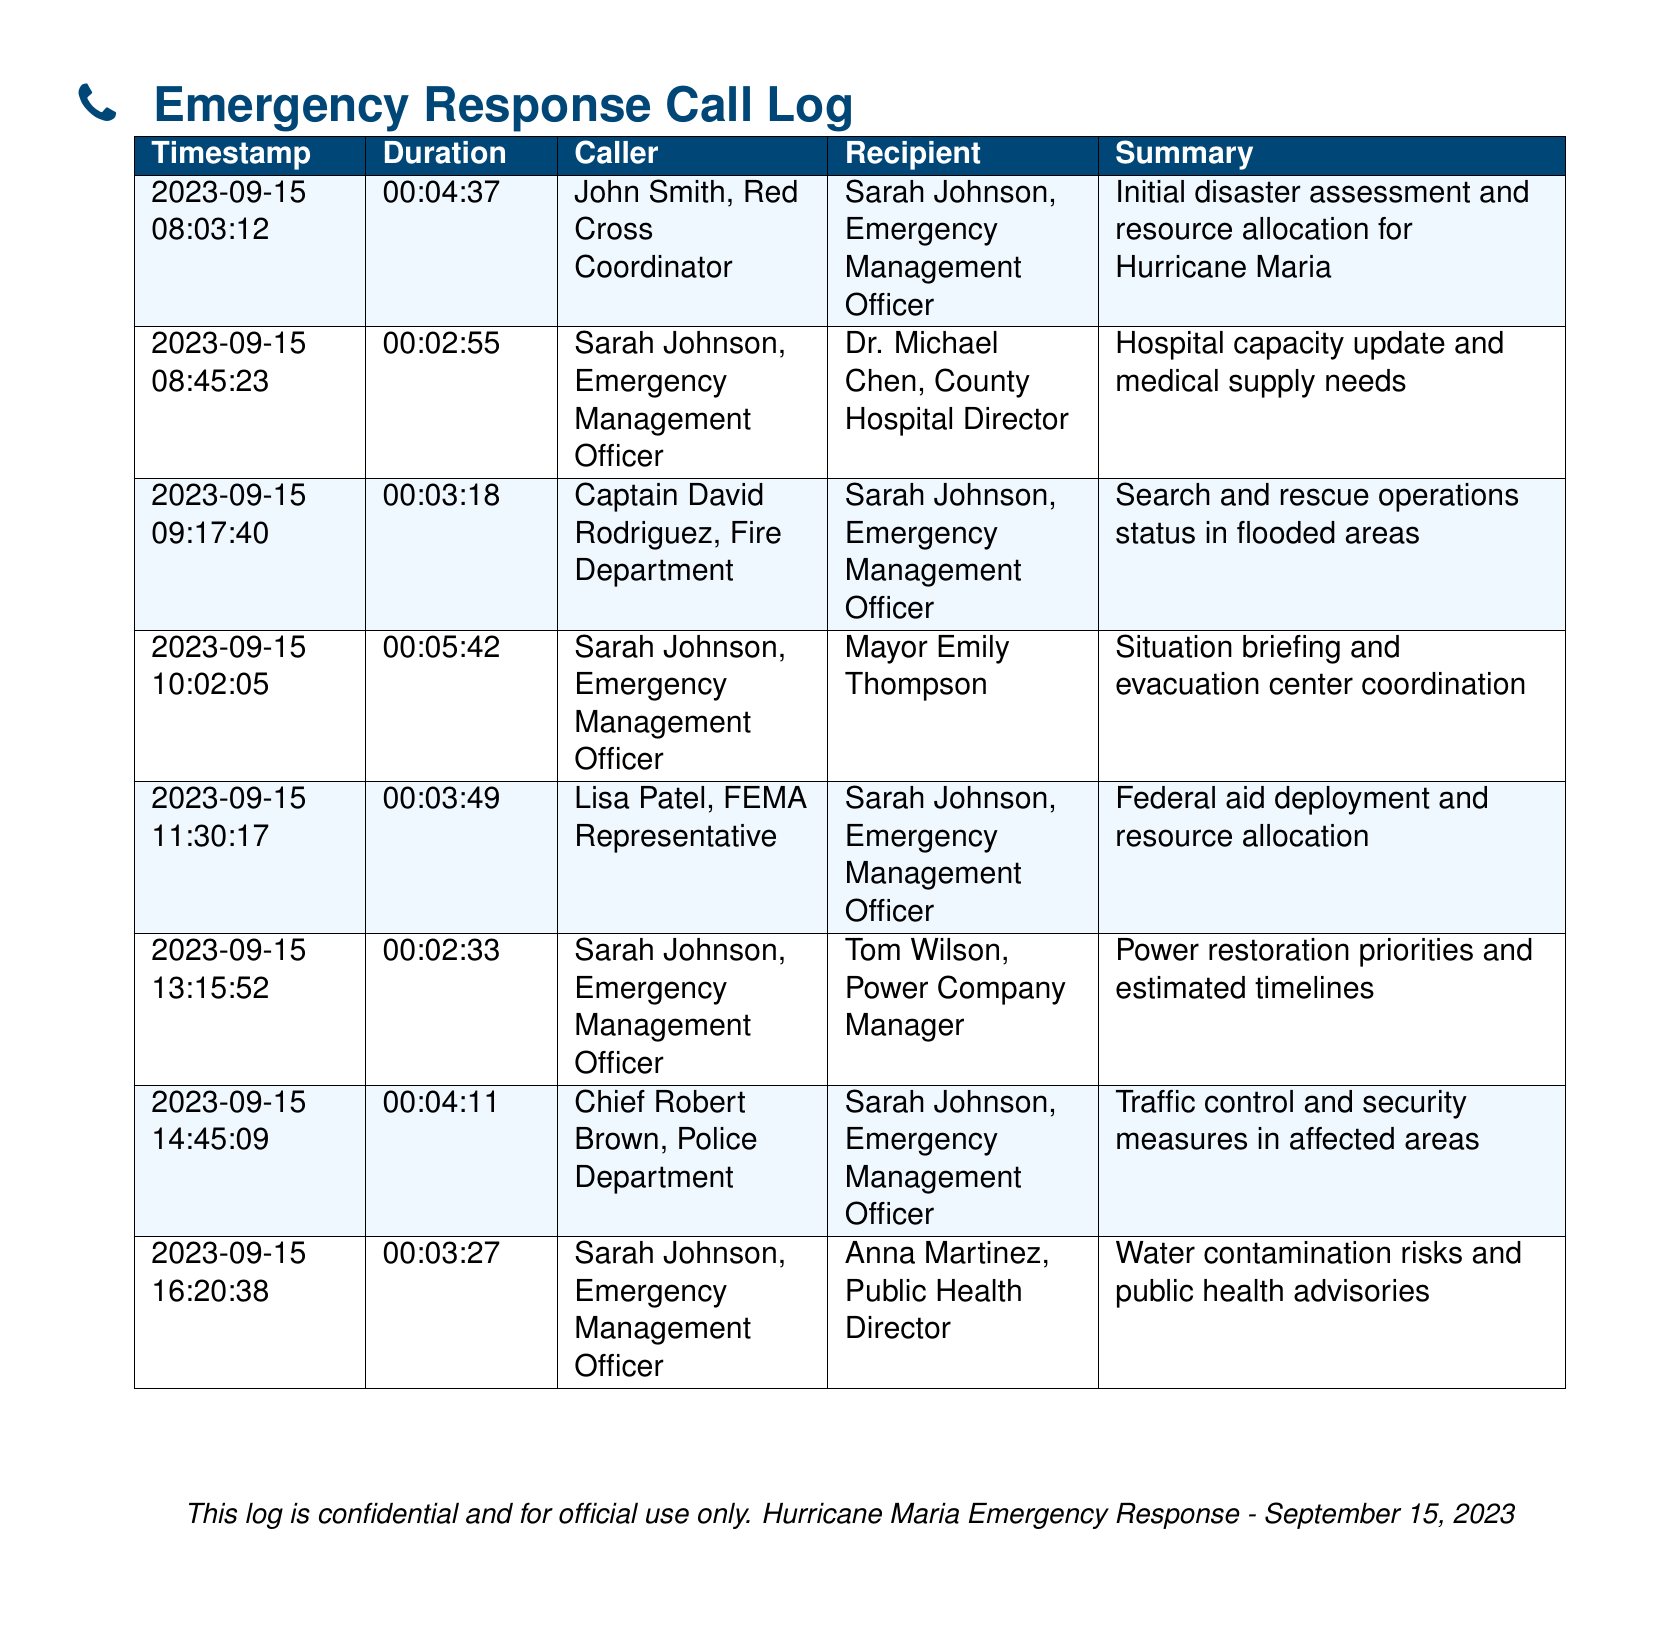what is the duration of the first call? The duration of the first call is recorded in the document under the Duration column for that call’s row.
Answer: 00:04:37 who was the caller in the fourth call? The caller in the fourth call is identified in the Caller column for that specific row.
Answer: Sarah Johnson, Emergency Management Officer what time was the last call made? The last call's time is the Timestamp shown at the end of the log, which is specifically formatted in a date and time format.
Answer: 16:20:38 how many calls were made by Sarah Johnson? To find the number of calls made by Sarah Johnson, count the number of times her name appears in the Caller column throughout the document.
Answer: 5 which organization does Lisa Patel represent? The organization Lisa Patel represents is noted alongside her name in the Caller column of the records.
Answer: FEMA what was discussed in the third call? The summary of the third call specifies the main topic discussed, as recorded in the Summary column of that row.
Answer: Search and rescue operations status in flooded areas how long was the shortest call? To find the shortest call, compare the durations in the Duration column and identify the minimum value.
Answer: 00:02:33 who was the recipient of the second call? The recipient's name is listed in the Recipient column associated with the second call entry in the log.
Answer: Dr. Michael Chen, County Hospital Director what is the date of the emergency response log? The date of the log is indicated in the Timestamp of the first entry of the document, formatted as year, month, and day.
Answer: 2023-09-15 